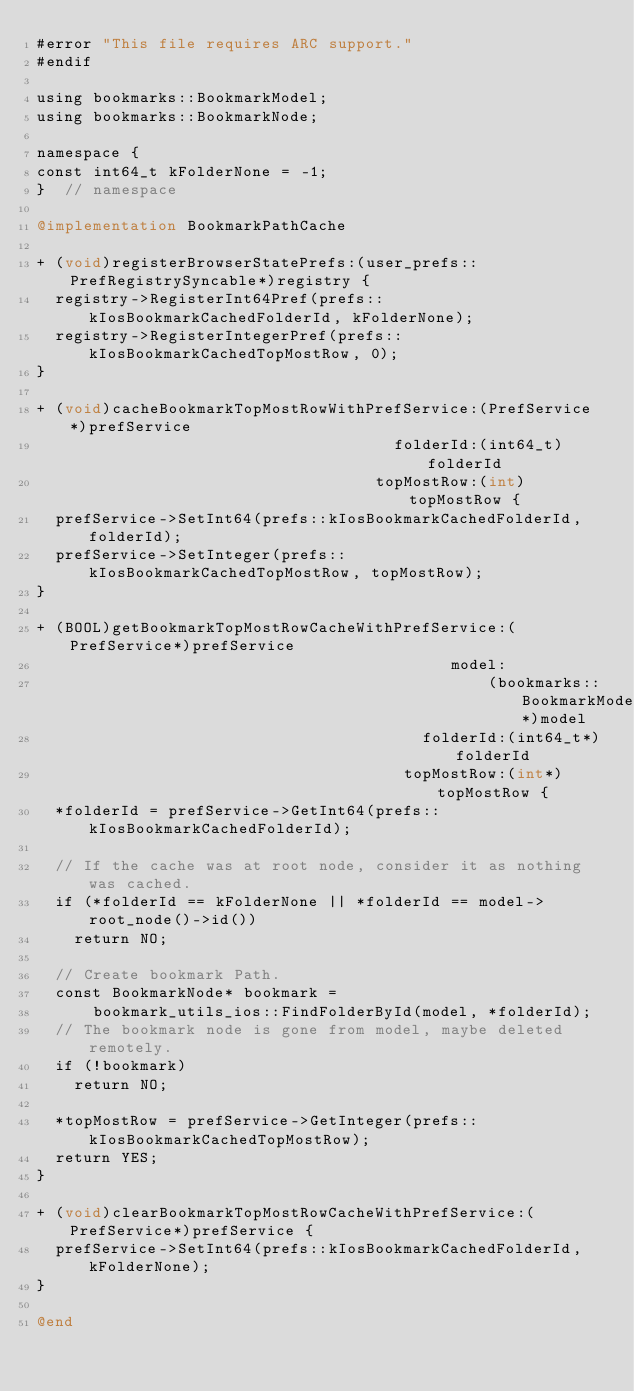Convert code to text. <code><loc_0><loc_0><loc_500><loc_500><_ObjectiveC_>#error "This file requires ARC support."
#endif

using bookmarks::BookmarkModel;
using bookmarks::BookmarkNode;

namespace {
const int64_t kFolderNone = -1;
}  // namespace

@implementation BookmarkPathCache

+ (void)registerBrowserStatePrefs:(user_prefs::PrefRegistrySyncable*)registry {
  registry->RegisterInt64Pref(prefs::kIosBookmarkCachedFolderId, kFolderNone);
  registry->RegisterIntegerPref(prefs::kIosBookmarkCachedTopMostRow, 0);
}

+ (void)cacheBookmarkTopMostRowWithPrefService:(PrefService*)prefService
                                      folderId:(int64_t)folderId
                                    topMostRow:(int)topMostRow {
  prefService->SetInt64(prefs::kIosBookmarkCachedFolderId, folderId);
  prefService->SetInteger(prefs::kIosBookmarkCachedTopMostRow, topMostRow);
}

+ (BOOL)getBookmarkTopMostRowCacheWithPrefService:(PrefService*)prefService
                                            model:
                                                (bookmarks::BookmarkModel*)model
                                         folderId:(int64_t*)folderId
                                       topMostRow:(int*)topMostRow {
  *folderId = prefService->GetInt64(prefs::kIosBookmarkCachedFolderId);

  // If the cache was at root node, consider it as nothing was cached.
  if (*folderId == kFolderNone || *folderId == model->root_node()->id())
    return NO;

  // Create bookmark Path.
  const BookmarkNode* bookmark =
      bookmark_utils_ios::FindFolderById(model, *folderId);
  // The bookmark node is gone from model, maybe deleted remotely.
  if (!bookmark)
    return NO;

  *topMostRow = prefService->GetInteger(prefs::kIosBookmarkCachedTopMostRow);
  return YES;
}

+ (void)clearBookmarkTopMostRowCacheWithPrefService:(PrefService*)prefService {
  prefService->SetInt64(prefs::kIosBookmarkCachedFolderId, kFolderNone);
}

@end
</code> 